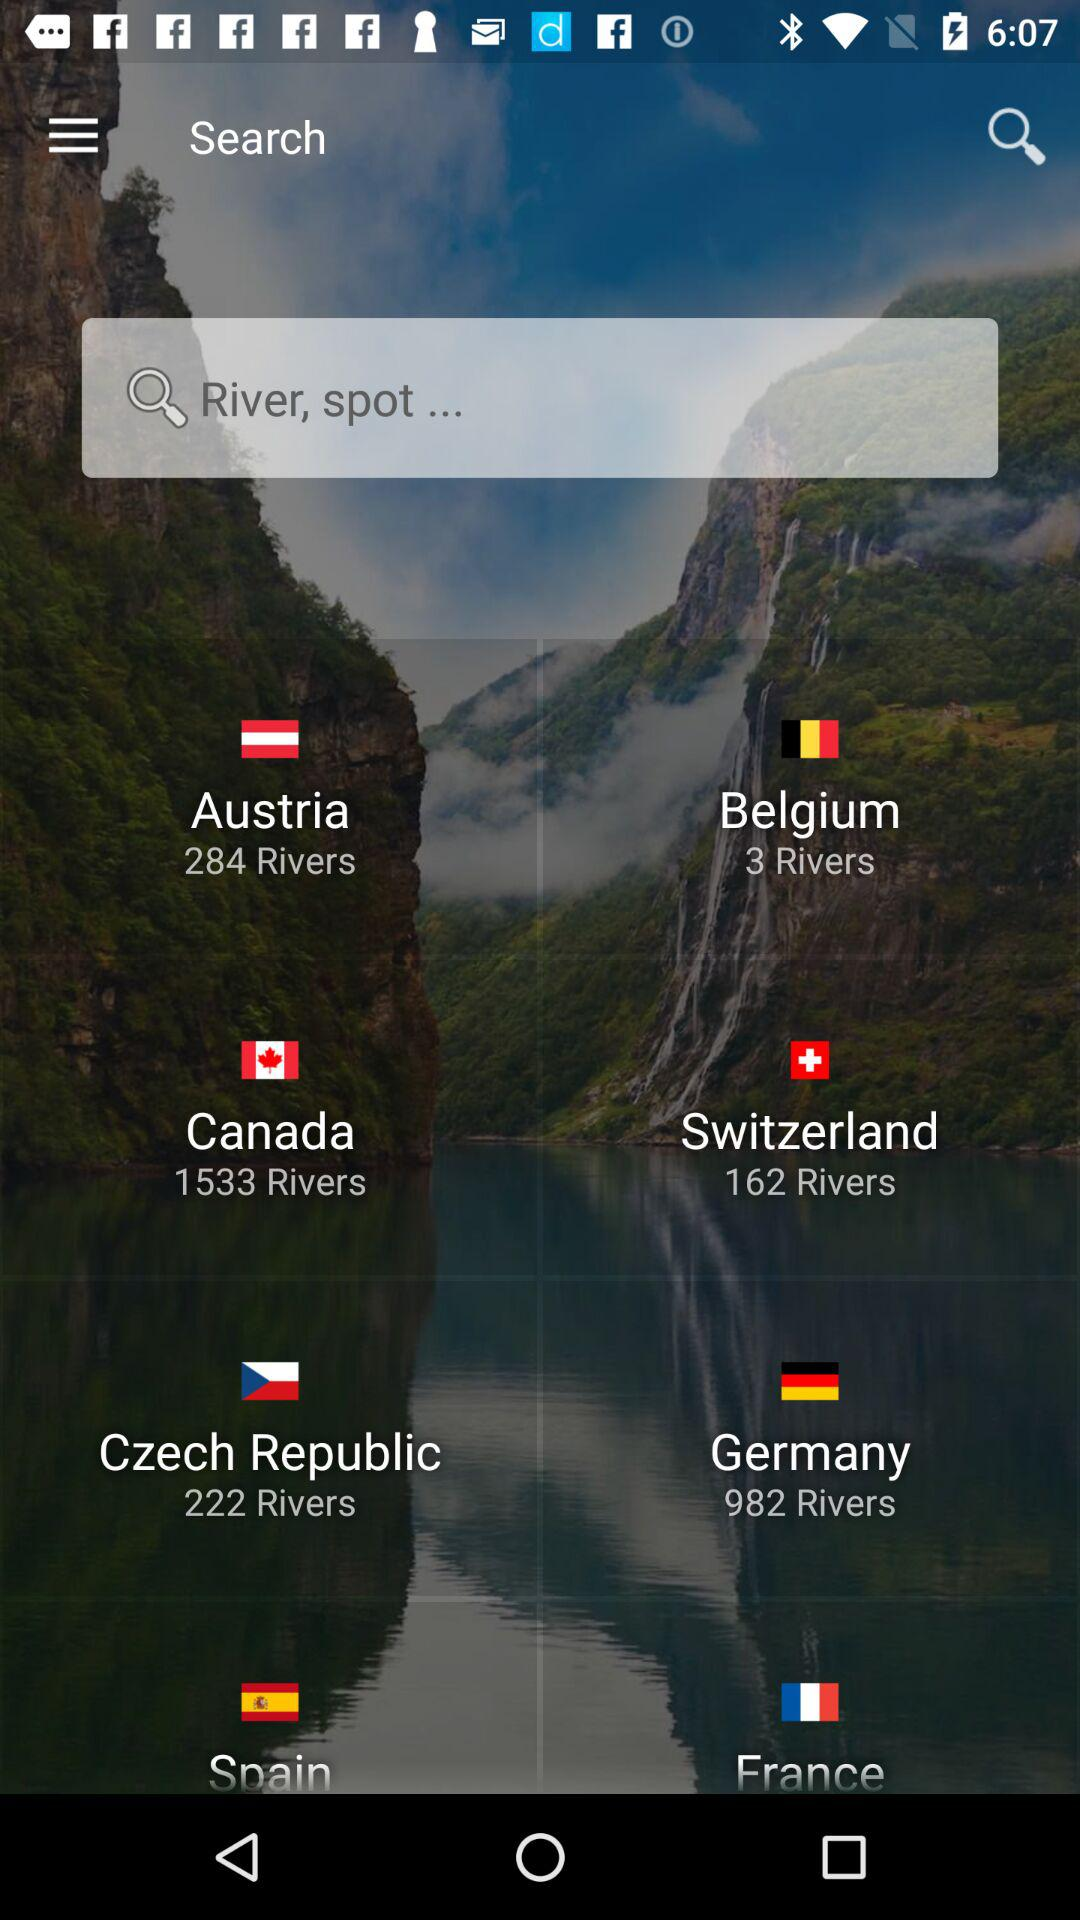How many more rivers are in Canada than Switzerland?
Answer the question using a single word or phrase. 1371 